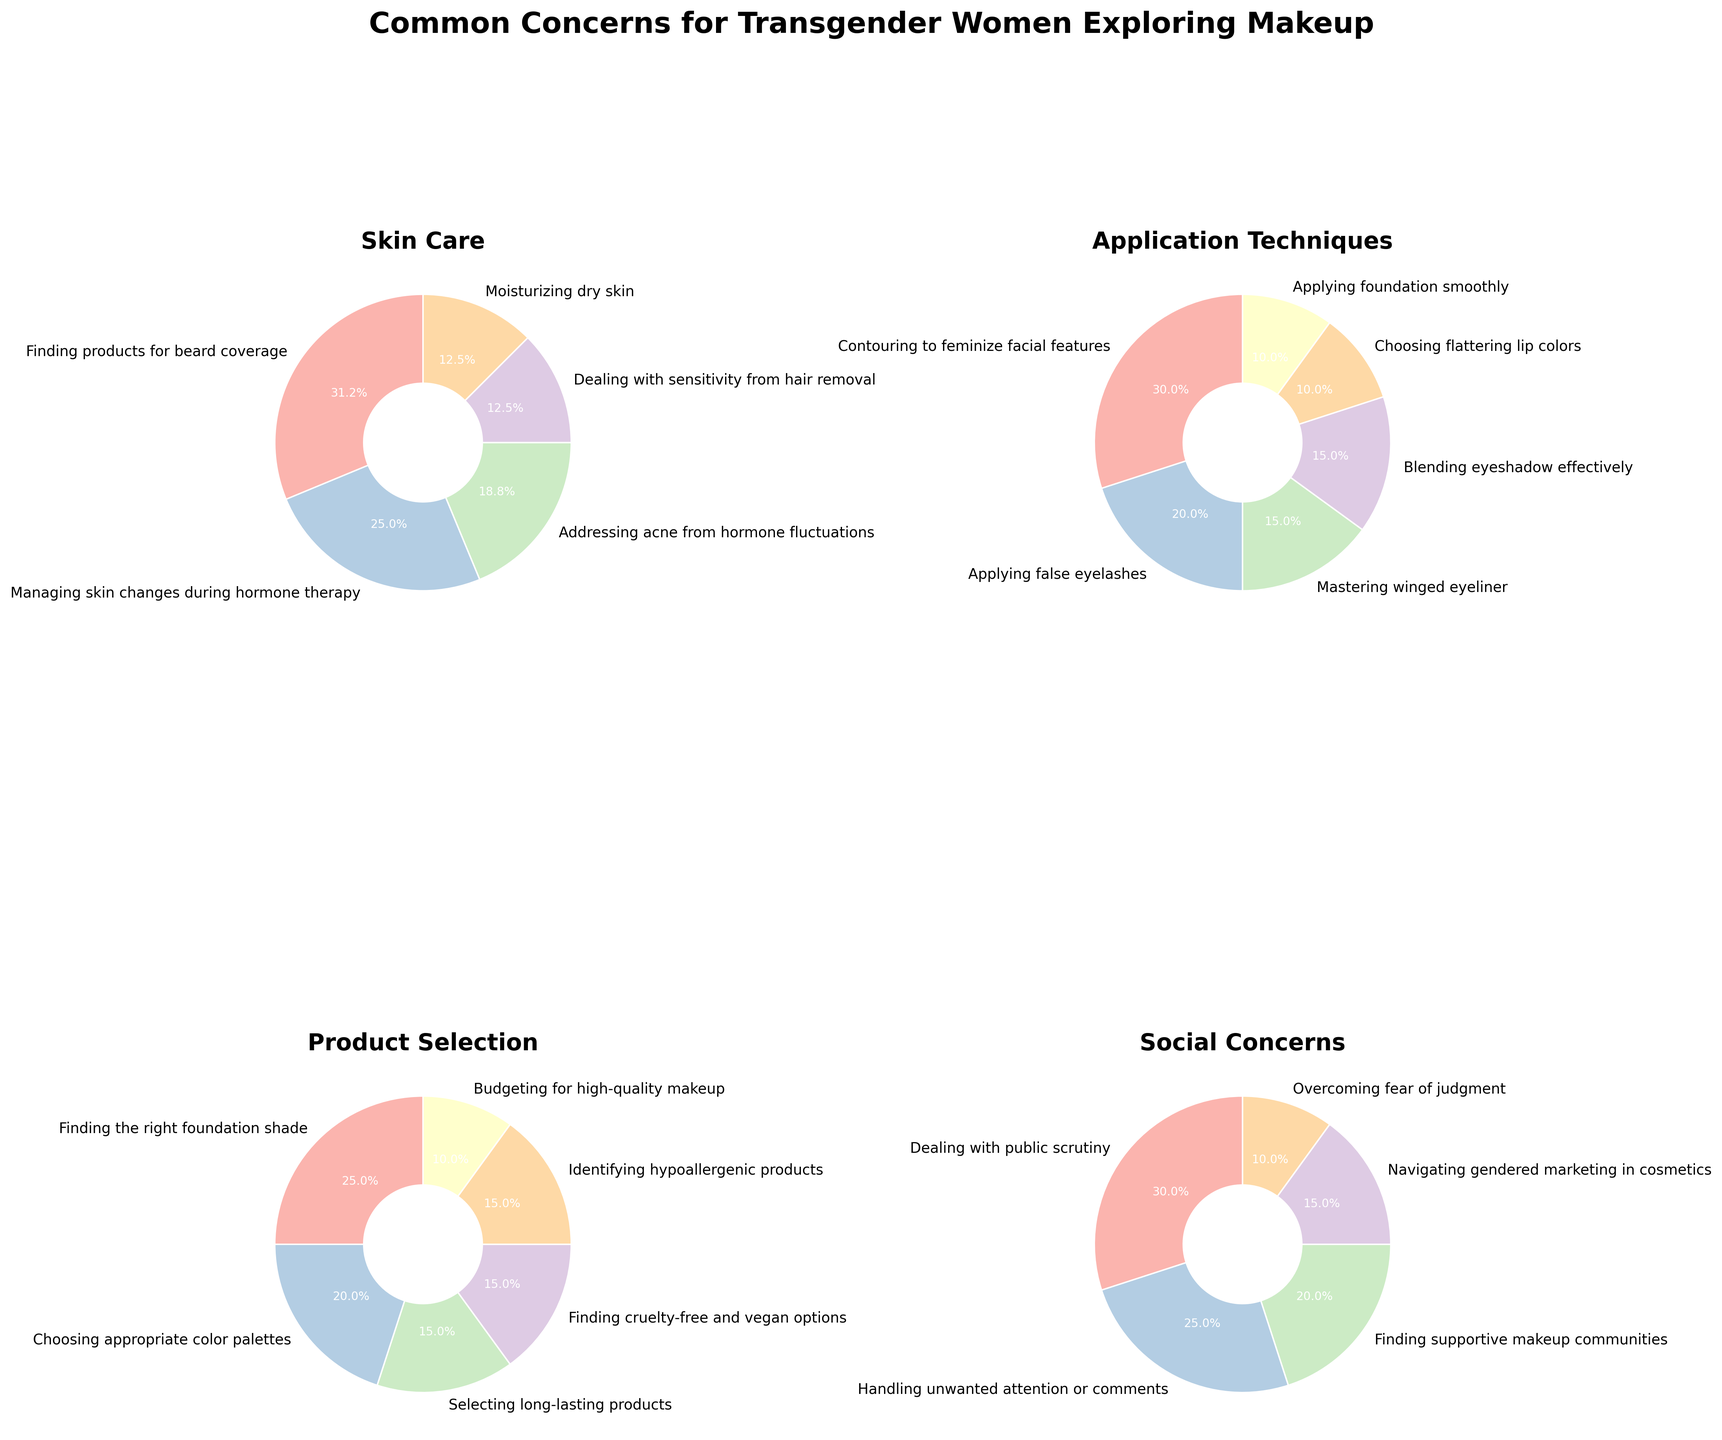Which category has the highest total percentage of concerns? To find the category with the highest total percentage, sum up the percentages of concerns within each category. For Skin Care, the sum is 25 + 20 + 15 + 10 + 10 = 80. For Application Techniques, the sum is 30 + 20 + 15 + 15 + 10 + 10 = 100. For Product Selection, the sum is 25 + 20 + 15 + 15 + 15 + 10 = 100. For Social Concerns, the sum is 30 + 25 + 20 + 15 + 10 = 100. Comparing these totals, Application Techniques, Product Selection, and Social Concerns all have the highest total percentage of 100.
Answer: Application Techniques, Product Selection, and Social Concerns Which specific concern under Skin Care is the most prevalent? Under the Skin Care category, analyze the percentages of each concern. The percentages are 25 for Finding products for beard coverage, 20 for Managing skin changes during hormone therapy, 15 for Addressing acne from hormone fluctuations, 10 for Dealing with sensitivity from hair removal, and 10 for Moisturizing dry skin. The highest percentage is 25 for Finding products for beard coverage.
Answer: Finding products for beard coverage What is the percentage difference between Contouring to feminize facial features and Applying false eyelashes in the Application Techniques category? First, obtain the percentages for the concerns: Contouring to feminize facial features has 30 and Applying false eyelashes has 20. The difference is 30 - 20 = 10.
Answer: 10 Which concern has the smallest percentage in the Product Selection category? Identify the percentages for all concerns under Product Selection. The concerns are: Finding the right foundation shade (25), Choosing appropriate color palettes (20), Selecting long-lasting products (15), Finding cruelty-free and vegan options (15), Identifying hypoallergenic products (15), and Budgeting for high-quality makeup (10). The smallest percentage is 10 for Budgeting for high-quality makeup.
Answer: Budgeting for high-quality makeup What is the combined percentage for the top two concerns in Social Concerns? In the Social Concerns category, the top two percentages are for Dealing with public scrutiny (30) and Handling unwanted attention or comments (25). Adding these together gives 30 + 25 = 55.
Answer: 55 